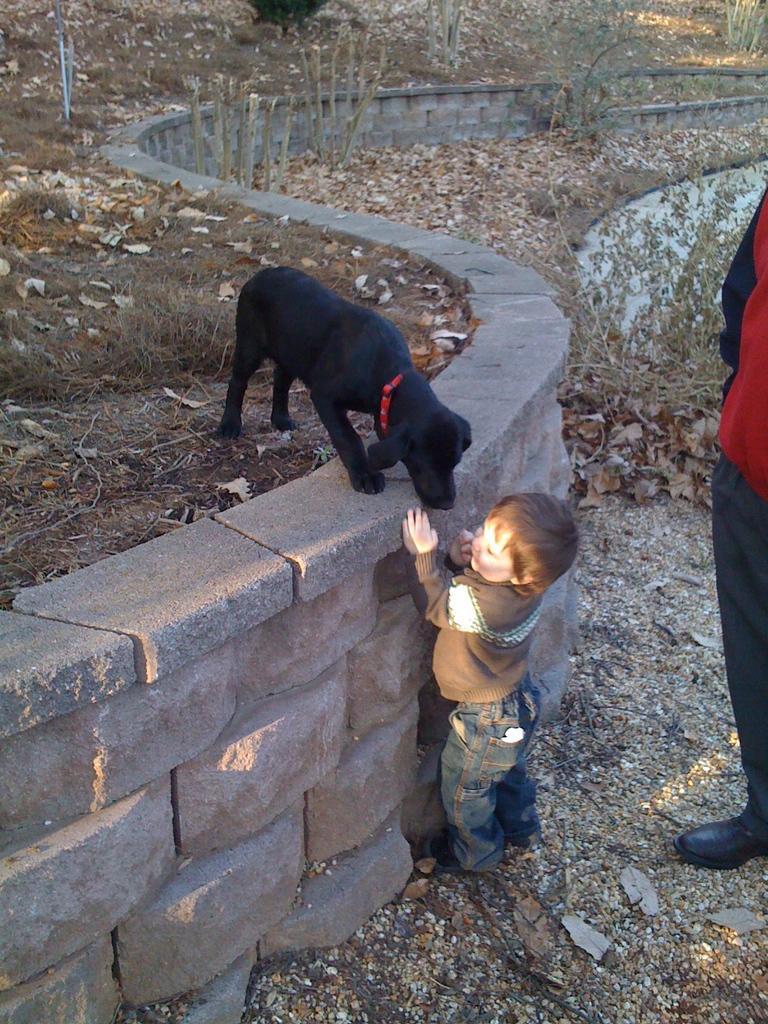Please provide a concise description of this image. There is a small boy standing near the brick wall. On the wall there is a black dog. Near to the boy a person is standing. In the background there are small plants. On the floor there are dried leaves. 